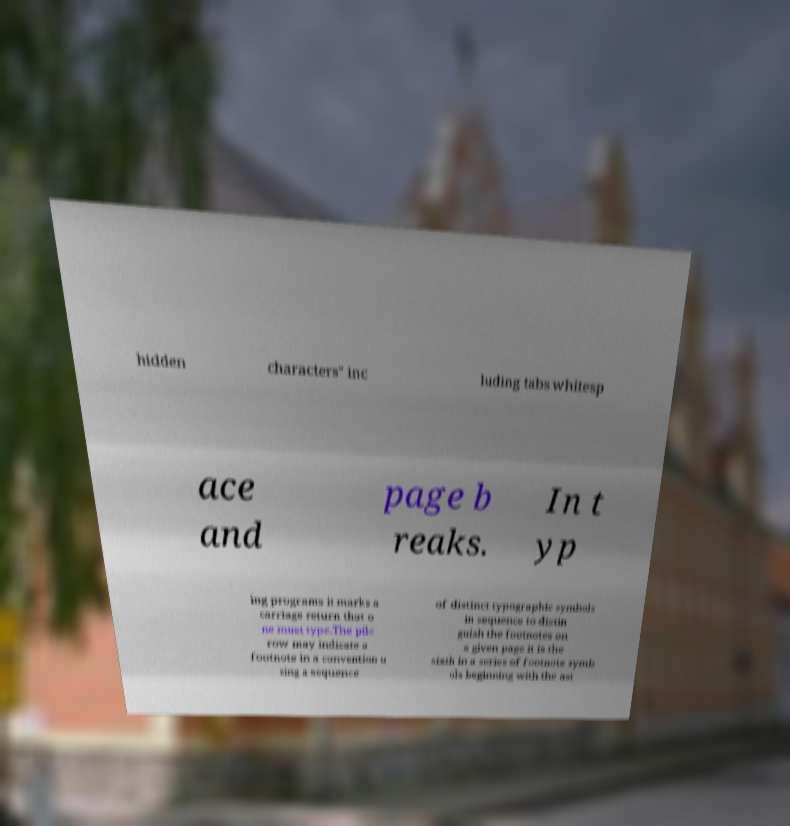I need the written content from this picture converted into text. Can you do that? hidden characters" inc luding tabs whitesp ace and page b reaks. In t yp ing programs it marks a carriage return that o ne must type.The pilc row may indicate a footnote in a convention u sing a sequence of distinct typographic symbols in sequence to distin guish the footnotes on a given page it is the sixth in a series of footnote symb ols beginning with the ast 